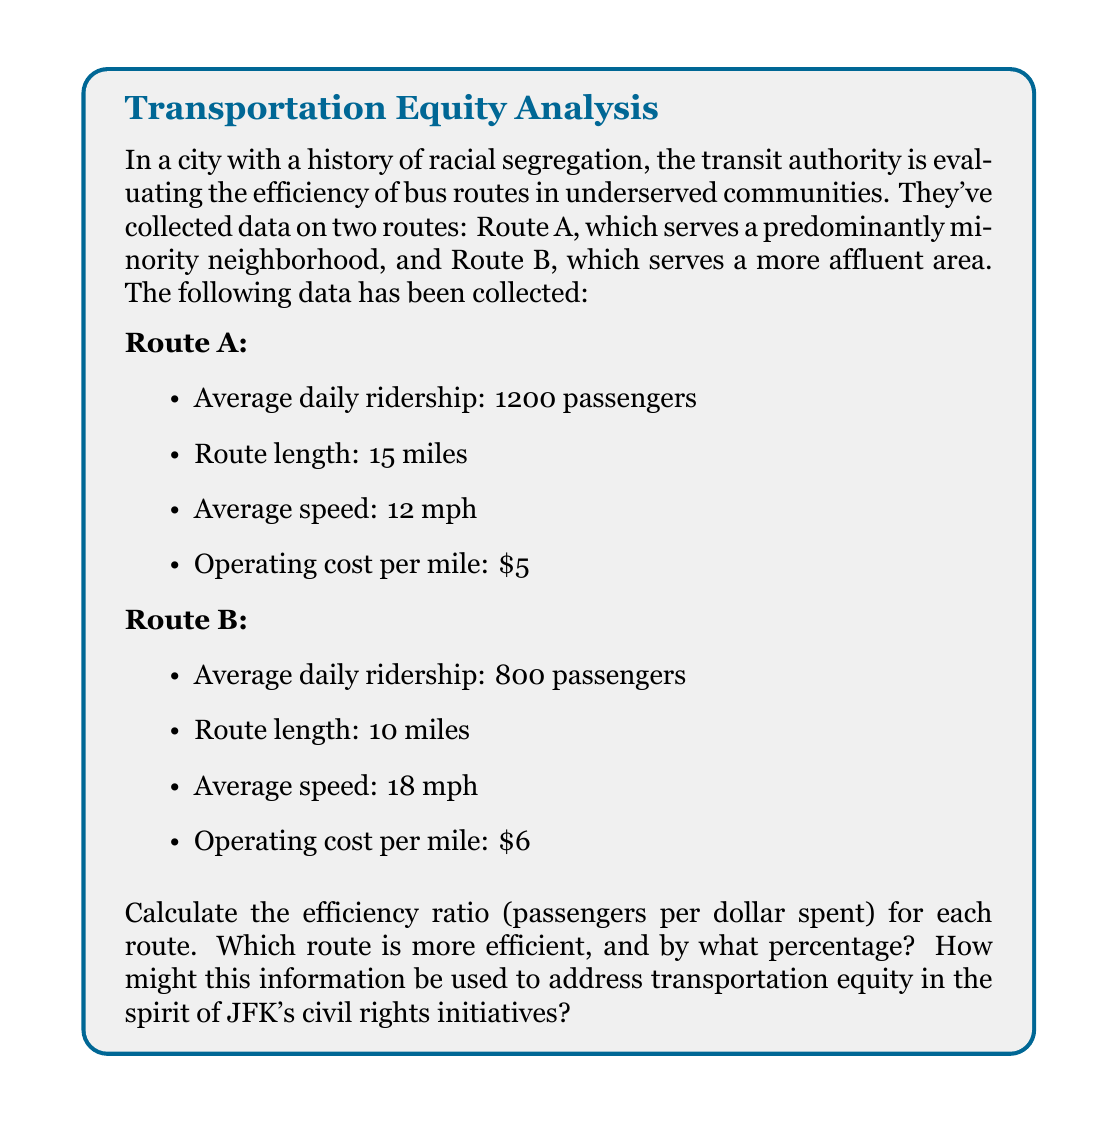Could you help me with this problem? To solve this problem, we need to follow these steps:

1. Calculate the total daily operating cost for each route:
   - Route A: $\text{Cost}_A = \text{Length}_A \times \text{Cost per mile}_A$
   - Route B: $\text{Cost}_B = \text{Length}_B \times \text{Cost per mile}_B$

2. Calculate the efficiency ratio (passengers per dollar spent) for each route:
   - Efficiency Ratio = $\frac{\text{Average daily ridership}}{\text{Total daily operating cost}}$

3. Compare the efficiency ratios and calculate the percentage difference.

Let's go through each step:

1. Total daily operating cost:
   - Route A: $\text{Cost}_A = 15 \text{ miles} \times \$5/\text{mile} = \$75$
   - Route B: $\text{Cost}_B = 10 \text{ miles} \times \$6/\text{mile} = \$60$

2. Efficiency ratio:
   - Route A: $\text{Efficiency}_A = \frac{1200 \text{ passengers}}{\$75} = 16 \text{ passengers/dollar}$
   - Route B: $\text{Efficiency}_B = \frac{800 \text{ passengers}}{\$60} = 13.33 \text{ passengers/dollar}$

3. Comparison:
   Route A is more efficient. To calculate the percentage difference:

   $\text{Percentage difference} = \frac{\text{Efficiency}_A - \text{Efficiency}_B}{\text{Efficiency}_B} \times 100\%$

   $= \frac{16 - 13.33}{13.33} \times 100\% = 20\%$

This information can be used to address transportation equity by demonstrating that the route serving the predominantly minority neighborhood (Route A) is actually more efficient in terms of passengers served per dollar spent. This aligns with JFK's civil rights initiatives by highlighting the importance of investing in underserved communities and ensuring equal access to public services. The transit authority could use this data to justify maintaining or even expanding service in the minority neighborhood, potentially allocating more resources to Route A to further improve its efficiency and service quality.
Answer: Route A is more efficient with 16 passengers/dollar compared to Route B's 13.33 passengers/dollar. Route A is 20% more efficient than Route B. 